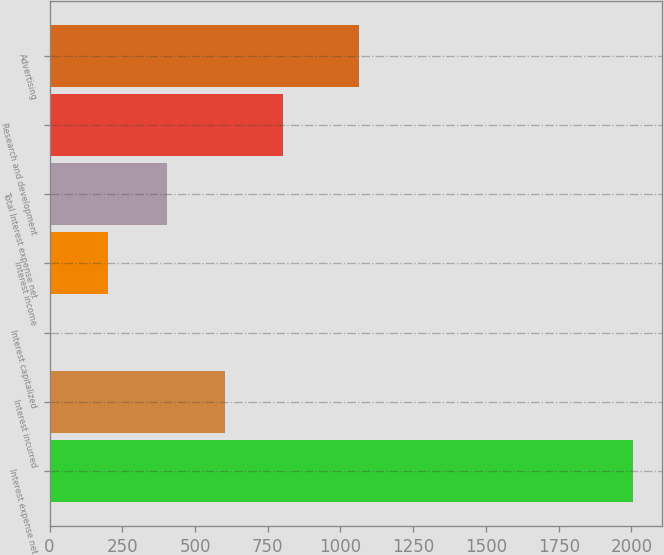Convert chart. <chart><loc_0><loc_0><loc_500><loc_500><bar_chart><fcel>Interest expense net<fcel>Interest incurred<fcel>Interest capitalized<fcel>Interest income<fcel>Total Interest expense net<fcel>Research and development<fcel>Advertising<nl><fcel>2004<fcel>602.81<fcel>2.3<fcel>202.47<fcel>402.64<fcel>802.98<fcel>1063<nl></chart> 